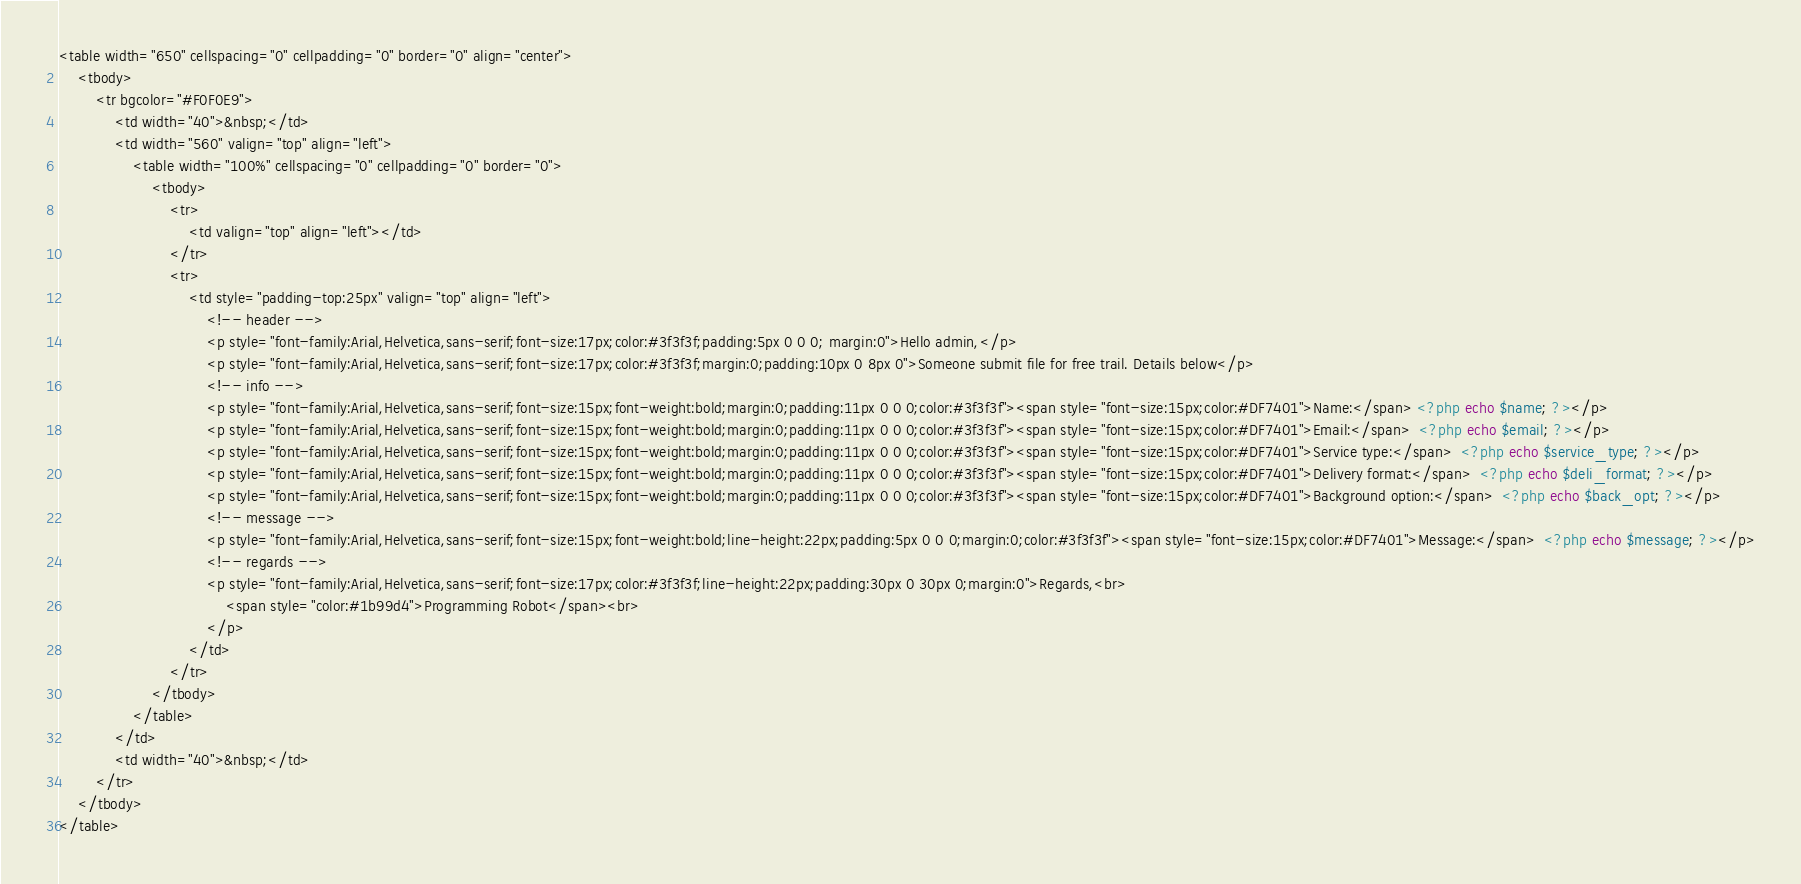Convert code to text. <code><loc_0><loc_0><loc_500><loc_500><_PHP_><table width="650" cellspacing="0" cellpadding="0" border="0" align="center">
    <tbody>
        <tr bgcolor="#F0F0E9">
            <td width="40">&nbsp;</td>
            <td width="560" valign="top" align="left">
                <table width="100%" cellspacing="0" cellpadding="0" border="0">
                    <tbody>
                        <tr>
                            <td valign="top" align="left"></td>
                        </tr>
                        <tr>
                            <td style="padding-top:25px" valign="top" align="left">
                                <!-- header -->
                                <p style="font-family:Arial,Helvetica,sans-serif;font-size:17px;color:#3f3f3f;padding:5px 0 0 0; margin:0">Hello admin,</p>
                                <p style="font-family:Arial,Helvetica,sans-serif;font-size:17px;color:#3f3f3f;margin:0;padding:10px 0 8px 0">Someone submit file for free trail. Details below</p>
                                <!-- info -->
                                <p style="font-family:Arial,Helvetica,sans-serif;font-size:15px;font-weight:bold;margin:0;padding:11px 0 0 0;color:#3f3f3f"><span style="font-size:15px;color:#DF7401">Name:</span> <?php echo $name; ?></p>
                                <p style="font-family:Arial,Helvetica,sans-serif;font-size:15px;font-weight:bold;margin:0;padding:11px 0 0 0;color:#3f3f3f"><span style="font-size:15px;color:#DF7401">Email:</span>  <?php echo $email; ?></p>
                                <p style="font-family:Arial,Helvetica,sans-serif;font-size:15px;font-weight:bold;margin:0;padding:11px 0 0 0;color:#3f3f3f"><span style="font-size:15px;color:#DF7401">Service type:</span>  <?php echo $service_type; ?></p>
                                <p style="font-family:Arial,Helvetica,sans-serif;font-size:15px;font-weight:bold;margin:0;padding:11px 0 0 0;color:#3f3f3f"><span style="font-size:15px;color:#DF7401">Delivery format:</span>  <?php echo $deli_format; ?></p>
                                <p style="font-family:Arial,Helvetica,sans-serif;font-size:15px;font-weight:bold;margin:0;padding:11px 0 0 0;color:#3f3f3f"><span style="font-size:15px;color:#DF7401">Background option:</span>  <?php echo $back_opt; ?></p>
                                <!-- message -->
                                <p style="font-family:Arial,Helvetica,sans-serif;font-size:15px;font-weight:bold;line-height:22px;padding:5px 0 0 0;margin:0;color:#3f3f3f"><span style="font-size:15px;color:#DF7401">Message:</span>  <?php echo $message; ?></p>
                                <!-- regards -->
                                <p style="font-family:Arial,Helvetica,sans-serif;font-size:17px;color:#3f3f3f;line-height:22px;padding:30px 0 30px 0;margin:0">Regards,<br>
                                    <span style="color:#1b99d4">Programming Robot</span><br>
                                </p>
                            </td>
                        </tr>
                    </tbody>
                </table>
            </td>
            <td width="40">&nbsp;</td>
        </tr>
    </tbody>
</table></code> 